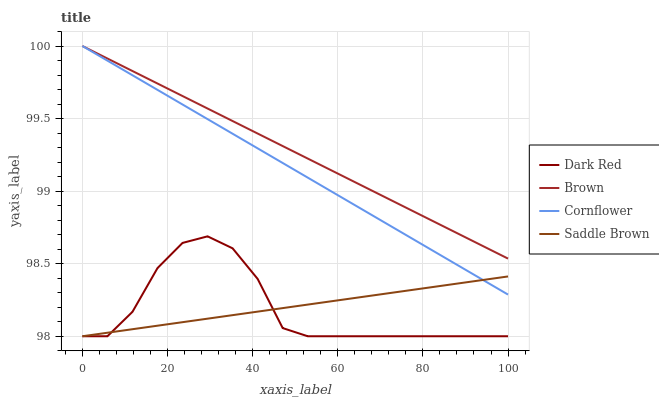Does Dark Red have the minimum area under the curve?
Answer yes or no. Yes. Does Brown have the maximum area under the curve?
Answer yes or no. Yes. Does Cornflower have the minimum area under the curve?
Answer yes or no. No. Does Cornflower have the maximum area under the curve?
Answer yes or no. No. Is Saddle Brown the smoothest?
Answer yes or no. Yes. Is Dark Red the roughest?
Answer yes or no. Yes. Is Cornflower the smoothest?
Answer yes or no. No. Is Cornflower the roughest?
Answer yes or no. No. Does Cornflower have the lowest value?
Answer yes or no. No. Does Brown have the highest value?
Answer yes or no. Yes. Does Dark Red have the highest value?
Answer yes or no. No. Is Dark Red less than Brown?
Answer yes or no. Yes. Is Brown greater than Dark Red?
Answer yes or no. Yes. Does Cornflower intersect Brown?
Answer yes or no. Yes. Is Cornflower less than Brown?
Answer yes or no. No. Is Cornflower greater than Brown?
Answer yes or no. No. Does Dark Red intersect Brown?
Answer yes or no. No. 